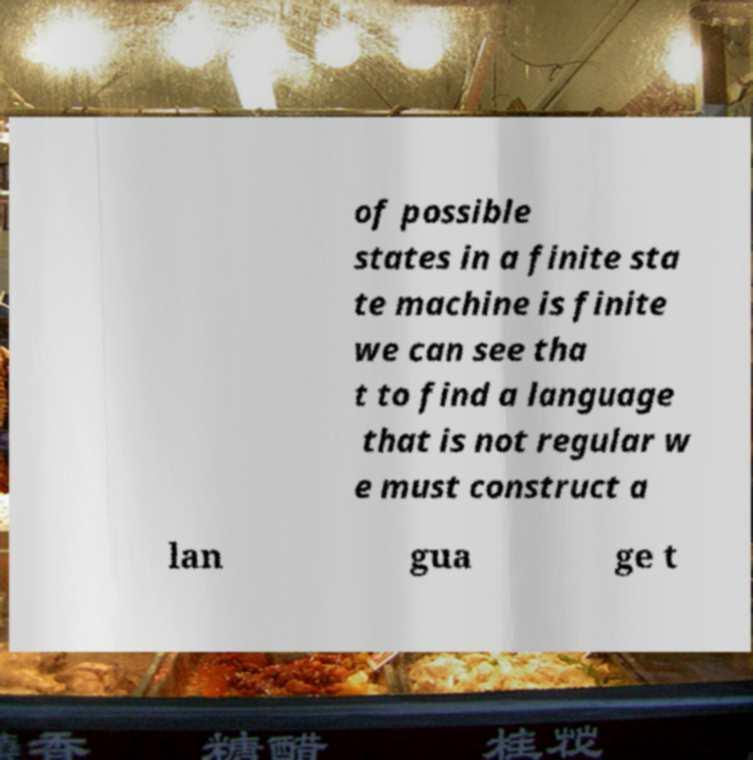I need the written content from this picture converted into text. Can you do that? of possible states in a finite sta te machine is finite we can see tha t to find a language that is not regular w e must construct a lan gua ge t 